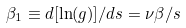Convert formula to latex. <formula><loc_0><loc_0><loc_500><loc_500>\beta _ { 1 } \equiv d [ \ln ( g ) ] / d s = \nu \beta / s</formula> 